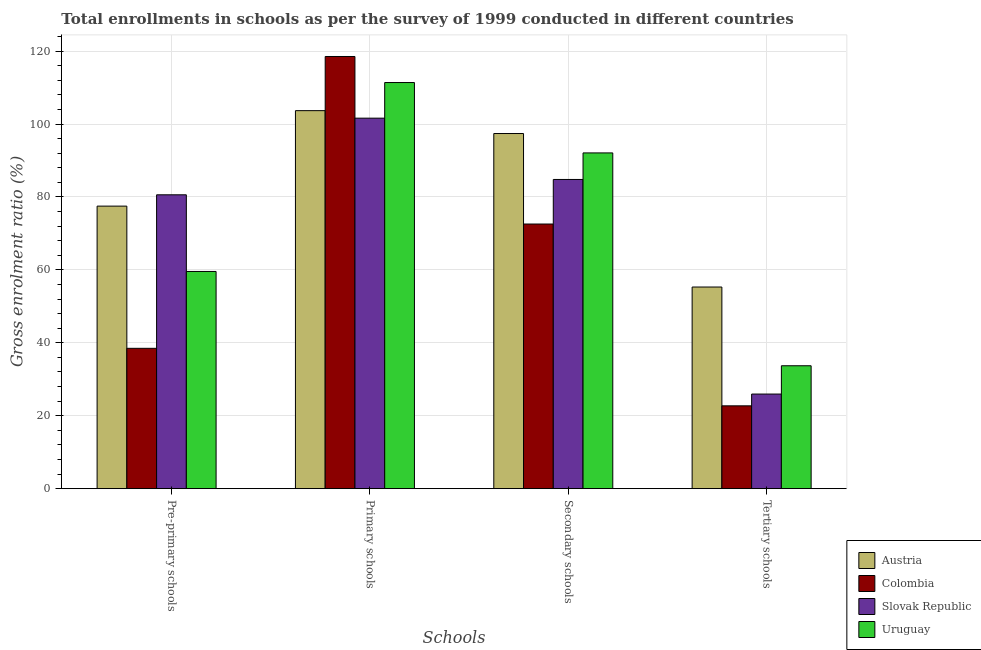How many different coloured bars are there?
Your answer should be compact. 4. Are the number of bars per tick equal to the number of legend labels?
Make the answer very short. Yes. How many bars are there on the 2nd tick from the left?
Your response must be concise. 4. How many bars are there on the 2nd tick from the right?
Offer a very short reply. 4. What is the label of the 1st group of bars from the left?
Your answer should be compact. Pre-primary schools. What is the gross enrolment ratio in pre-primary schools in Uruguay?
Keep it short and to the point. 59.57. Across all countries, what is the maximum gross enrolment ratio in pre-primary schools?
Ensure brevity in your answer.  80.59. Across all countries, what is the minimum gross enrolment ratio in secondary schools?
Offer a terse response. 72.58. In which country was the gross enrolment ratio in primary schools minimum?
Your answer should be very brief. Slovak Republic. What is the total gross enrolment ratio in secondary schools in the graph?
Your answer should be compact. 346.85. What is the difference between the gross enrolment ratio in tertiary schools in Uruguay and that in Colombia?
Your response must be concise. 10.99. What is the difference between the gross enrolment ratio in pre-primary schools in Austria and the gross enrolment ratio in primary schools in Colombia?
Make the answer very short. -41.03. What is the average gross enrolment ratio in tertiary schools per country?
Your answer should be very brief. 34.42. What is the difference between the gross enrolment ratio in tertiary schools and gross enrolment ratio in pre-primary schools in Austria?
Give a very brief answer. -22.19. In how many countries, is the gross enrolment ratio in primary schools greater than 64 %?
Provide a short and direct response. 4. What is the ratio of the gross enrolment ratio in primary schools in Austria to that in Slovak Republic?
Provide a short and direct response. 1.02. Is the gross enrolment ratio in pre-primary schools in Uruguay less than that in Colombia?
Give a very brief answer. No. What is the difference between the highest and the second highest gross enrolment ratio in primary schools?
Ensure brevity in your answer.  7.14. What is the difference between the highest and the lowest gross enrolment ratio in primary schools?
Your answer should be very brief. 16.91. Is it the case that in every country, the sum of the gross enrolment ratio in secondary schools and gross enrolment ratio in primary schools is greater than the sum of gross enrolment ratio in tertiary schools and gross enrolment ratio in pre-primary schools?
Offer a terse response. Yes. What does the 3rd bar from the left in Primary schools represents?
Make the answer very short. Slovak Republic. How many bars are there?
Provide a succinct answer. 16. Are all the bars in the graph horizontal?
Provide a short and direct response. No. How many countries are there in the graph?
Ensure brevity in your answer.  4. Are the values on the major ticks of Y-axis written in scientific E-notation?
Offer a very short reply. No. Does the graph contain grids?
Your response must be concise. Yes. Where does the legend appear in the graph?
Your response must be concise. Bottom right. How many legend labels are there?
Offer a very short reply. 4. What is the title of the graph?
Offer a very short reply. Total enrollments in schools as per the survey of 1999 conducted in different countries. What is the label or title of the X-axis?
Your answer should be compact. Schools. What is the label or title of the Y-axis?
Your answer should be very brief. Gross enrolment ratio (%). What is the Gross enrolment ratio (%) in Austria in Pre-primary schools?
Make the answer very short. 77.49. What is the Gross enrolment ratio (%) in Colombia in Pre-primary schools?
Offer a terse response. 38.49. What is the Gross enrolment ratio (%) in Slovak Republic in Pre-primary schools?
Offer a very short reply. 80.59. What is the Gross enrolment ratio (%) of Uruguay in Pre-primary schools?
Provide a short and direct response. 59.57. What is the Gross enrolment ratio (%) in Austria in Primary schools?
Your answer should be compact. 103.67. What is the Gross enrolment ratio (%) of Colombia in Primary schools?
Make the answer very short. 118.52. What is the Gross enrolment ratio (%) in Slovak Republic in Primary schools?
Offer a terse response. 101.61. What is the Gross enrolment ratio (%) in Uruguay in Primary schools?
Your response must be concise. 111.38. What is the Gross enrolment ratio (%) in Austria in Secondary schools?
Keep it short and to the point. 97.39. What is the Gross enrolment ratio (%) of Colombia in Secondary schools?
Provide a short and direct response. 72.58. What is the Gross enrolment ratio (%) in Slovak Republic in Secondary schools?
Make the answer very short. 84.8. What is the Gross enrolment ratio (%) in Uruguay in Secondary schools?
Provide a succinct answer. 92.08. What is the Gross enrolment ratio (%) in Austria in Tertiary schools?
Your answer should be very brief. 55.3. What is the Gross enrolment ratio (%) of Colombia in Tertiary schools?
Make the answer very short. 22.72. What is the Gross enrolment ratio (%) in Slovak Republic in Tertiary schools?
Keep it short and to the point. 25.95. What is the Gross enrolment ratio (%) in Uruguay in Tertiary schools?
Give a very brief answer. 33.71. Across all Schools, what is the maximum Gross enrolment ratio (%) of Austria?
Offer a very short reply. 103.67. Across all Schools, what is the maximum Gross enrolment ratio (%) in Colombia?
Your answer should be compact. 118.52. Across all Schools, what is the maximum Gross enrolment ratio (%) in Slovak Republic?
Keep it short and to the point. 101.61. Across all Schools, what is the maximum Gross enrolment ratio (%) in Uruguay?
Your response must be concise. 111.38. Across all Schools, what is the minimum Gross enrolment ratio (%) of Austria?
Provide a short and direct response. 55.3. Across all Schools, what is the minimum Gross enrolment ratio (%) in Colombia?
Ensure brevity in your answer.  22.72. Across all Schools, what is the minimum Gross enrolment ratio (%) of Slovak Republic?
Offer a terse response. 25.95. Across all Schools, what is the minimum Gross enrolment ratio (%) in Uruguay?
Keep it short and to the point. 33.71. What is the total Gross enrolment ratio (%) of Austria in the graph?
Offer a terse response. 333.85. What is the total Gross enrolment ratio (%) of Colombia in the graph?
Your answer should be compact. 252.31. What is the total Gross enrolment ratio (%) in Slovak Republic in the graph?
Ensure brevity in your answer.  292.94. What is the total Gross enrolment ratio (%) of Uruguay in the graph?
Offer a very short reply. 296.73. What is the difference between the Gross enrolment ratio (%) of Austria in Pre-primary schools and that in Primary schools?
Provide a succinct answer. -26.18. What is the difference between the Gross enrolment ratio (%) in Colombia in Pre-primary schools and that in Primary schools?
Provide a short and direct response. -80.03. What is the difference between the Gross enrolment ratio (%) of Slovak Republic in Pre-primary schools and that in Primary schools?
Your response must be concise. -21.02. What is the difference between the Gross enrolment ratio (%) of Uruguay in Pre-primary schools and that in Primary schools?
Keep it short and to the point. -51.81. What is the difference between the Gross enrolment ratio (%) in Austria in Pre-primary schools and that in Secondary schools?
Your answer should be very brief. -19.9. What is the difference between the Gross enrolment ratio (%) of Colombia in Pre-primary schools and that in Secondary schools?
Provide a succinct answer. -34.09. What is the difference between the Gross enrolment ratio (%) in Slovak Republic in Pre-primary schools and that in Secondary schools?
Your response must be concise. -4.21. What is the difference between the Gross enrolment ratio (%) in Uruguay in Pre-primary schools and that in Secondary schools?
Offer a very short reply. -32.51. What is the difference between the Gross enrolment ratio (%) of Austria in Pre-primary schools and that in Tertiary schools?
Provide a short and direct response. 22.19. What is the difference between the Gross enrolment ratio (%) in Colombia in Pre-primary schools and that in Tertiary schools?
Provide a succinct answer. 15.77. What is the difference between the Gross enrolment ratio (%) of Slovak Republic in Pre-primary schools and that in Tertiary schools?
Offer a terse response. 54.64. What is the difference between the Gross enrolment ratio (%) of Uruguay in Pre-primary schools and that in Tertiary schools?
Your answer should be very brief. 25.86. What is the difference between the Gross enrolment ratio (%) in Austria in Primary schools and that in Secondary schools?
Make the answer very short. 6.28. What is the difference between the Gross enrolment ratio (%) in Colombia in Primary schools and that in Secondary schools?
Provide a short and direct response. 45.94. What is the difference between the Gross enrolment ratio (%) in Slovak Republic in Primary schools and that in Secondary schools?
Your answer should be very brief. 16.81. What is the difference between the Gross enrolment ratio (%) of Uruguay in Primary schools and that in Secondary schools?
Offer a very short reply. 19.3. What is the difference between the Gross enrolment ratio (%) in Austria in Primary schools and that in Tertiary schools?
Make the answer very short. 48.37. What is the difference between the Gross enrolment ratio (%) of Colombia in Primary schools and that in Tertiary schools?
Offer a terse response. 95.8. What is the difference between the Gross enrolment ratio (%) of Slovak Republic in Primary schools and that in Tertiary schools?
Your response must be concise. 75.66. What is the difference between the Gross enrolment ratio (%) of Uruguay in Primary schools and that in Tertiary schools?
Give a very brief answer. 77.67. What is the difference between the Gross enrolment ratio (%) in Austria in Secondary schools and that in Tertiary schools?
Your answer should be compact. 42.09. What is the difference between the Gross enrolment ratio (%) of Colombia in Secondary schools and that in Tertiary schools?
Offer a terse response. 49.86. What is the difference between the Gross enrolment ratio (%) in Slovak Republic in Secondary schools and that in Tertiary schools?
Ensure brevity in your answer.  58.85. What is the difference between the Gross enrolment ratio (%) of Uruguay in Secondary schools and that in Tertiary schools?
Ensure brevity in your answer.  58.37. What is the difference between the Gross enrolment ratio (%) of Austria in Pre-primary schools and the Gross enrolment ratio (%) of Colombia in Primary schools?
Ensure brevity in your answer.  -41.03. What is the difference between the Gross enrolment ratio (%) of Austria in Pre-primary schools and the Gross enrolment ratio (%) of Slovak Republic in Primary schools?
Ensure brevity in your answer.  -24.12. What is the difference between the Gross enrolment ratio (%) of Austria in Pre-primary schools and the Gross enrolment ratio (%) of Uruguay in Primary schools?
Make the answer very short. -33.89. What is the difference between the Gross enrolment ratio (%) of Colombia in Pre-primary schools and the Gross enrolment ratio (%) of Slovak Republic in Primary schools?
Make the answer very short. -63.12. What is the difference between the Gross enrolment ratio (%) of Colombia in Pre-primary schools and the Gross enrolment ratio (%) of Uruguay in Primary schools?
Ensure brevity in your answer.  -72.89. What is the difference between the Gross enrolment ratio (%) of Slovak Republic in Pre-primary schools and the Gross enrolment ratio (%) of Uruguay in Primary schools?
Make the answer very short. -30.79. What is the difference between the Gross enrolment ratio (%) of Austria in Pre-primary schools and the Gross enrolment ratio (%) of Colombia in Secondary schools?
Keep it short and to the point. 4.91. What is the difference between the Gross enrolment ratio (%) in Austria in Pre-primary schools and the Gross enrolment ratio (%) in Slovak Republic in Secondary schools?
Offer a very short reply. -7.31. What is the difference between the Gross enrolment ratio (%) of Austria in Pre-primary schools and the Gross enrolment ratio (%) of Uruguay in Secondary schools?
Your answer should be very brief. -14.59. What is the difference between the Gross enrolment ratio (%) in Colombia in Pre-primary schools and the Gross enrolment ratio (%) in Slovak Republic in Secondary schools?
Provide a short and direct response. -46.31. What is the difference between the Gross enrolment ratio (%) in Colombia in Pre-primary schools and the Gross enrolment ratio (%) in Uruguay in Secondary schools?
Offer a terse response. -53.59. What is the difference between the Gross enrolment ratio (%) in Slovak Republic in Pre-primary schools and the Gross enrolment ratio (%) in Uruguay in Secondary schools?
Keep it short and to the point. -11.49. What is the difference between the Gross enrolment ratio (%) in Austria in Pre-primary schools and the Gross enrolment ratio (%) in Colombia in Tertiary schools?
Keep it short and to the point. 54.77. What is the difference between the Gross enrolment ratio (%) in Austria in Pre-primary schools and the Gross enrolment ratio (%) in Slovak Republic in Tertiary schools?
Offer a very short reply. 51.54. What is the difference between the Gross enrolment ratio (%) in Austria in Pre-primary schools and the Gross enrolment ratio (%) in Uruguay in Tertiary schools?
Give a very brief answer. 43.78. What is the difference between the Gross enrolment ratio (%) in Colombia in Pre-primary schools and the Gross enrolment ratio (%) in Slovak Republic in Tertiary schools?
Provide a succinct answer. 12.54. What is the difference between the Gross enrolment ratio (%) in Colombia in Pre-primary schools and the Gross enrolment ratio (%) in Uruguay in Tertiary schools?
Provide a succinct answer. 4.78. What is the difference between the Gross enrolment ratio (%) in Slovak Republic in Pre-primary schools and the Gross enrolment ratio (%) in Uruguay in Tertiary schools?
Your answer should be very brief. 46.88. What is the difference between the Gross enrolment ratio (%) in Austria in Primary schools and the Gross enrolment ratio (%) in Colombia in Secondary schools?
Give a very brief answer. 31.09. What is the difference between the Gross enrolment ratio (%) of Austria in Primary schools and the Gross enrolment ratio (%) of Slovak Republic in Secondary schools?
Provide a short and direct response. 18.87. What is the difference between the Gross enrolment ratio (%) in Austria in Primary schools and the Gross enrolment ratio (%) in Uruguay in Secondary schools?
Keep it short and to the point. 11.59. What is the difference between the Gross enrolment ratio (%) in Colombia in Primary schools and the Gross enrolment ratio (%) in Slovak Republic in Secondary schools?
Your response must be concise. 33.72. What is the difference between the Gross enrolment ratio (%) in Colombia in Primary schools and the Gross enrolment ratio (%) in Uruguay in Secondary schools?
Provide a succinct answer. 26.44. What is the difference between the Gross enrolment ratio (%) of Slovak Republic in Primary schools and the Gross enrolment ratio (%) of Uruguay in Secondary schools?
Your answer should be compact. 9.53. What is the difference between the Gross enrolment ratio (%) of Austria in Primary schools and the Gross enrolment ratio (%) of Colombia in Tertiary schools?
Make the answer very short. 80.95. What is the difference between the Gross enrolment ratio (%) in Austria in Primary schools and the Gross enrolment ratio (%) in Slovak Republic in Tertiary schools?
Keep it short and to the point. 77.72. What is the difference between the Gross enrolment ratio (%) of Austria in Primary schools and the Gross enrolment ratio (%) of Uruguay in Tertiary schools?
Your answer should be very brief. 69.96. What is the difference between the Gross enrolment ratio (%) of Colombia in Primary schools and the Gross enrolment ratio (%) of Slovak Republic in Tertiary schools?
Provide a succinct answer. 92.57. What is the difference between the Gross enrolment ratio (%) of Colombia in Primary schools and the Gross enrolment ratio (%) of Uruguay in Tertiary schools?
Make the answer very short. 84.81. What is the difference between the Gross enrolment ratio (%) in Slovak Republic in Primary schools and the Gross enrolment ratio (%) in Uruguay in Tertiary schools?
Offer a terse response. 67.9. What is the difference between the Gross enrolment ratio (%) of Austria in Secondary schools and the Gross enrolment ratio (%) of Colombia in Tertiary schools?
Offer a terse response. 74.67. What is the difference between the Gross enrolment ratio (%) of Austria in Secondary schools and the Gross enrolment ratio (%) of Slovak Republic in Tertiary schools?
Give a very brief answer. 71.45. What is the difference between the Gross enrolment ratio (%) of Austria in Secondary schools and the Gross enrolment ratio (%) of Uruguay in Tertiary schools?
Provide a short and direct response. 63.68. What is the difference between the Gross enrolment ratio (%) in Colombia in Secondary schools and the Gross enrolment ratio (%) in Slovak Republic in Tertiary schools?
Keep it short and to the point. 46.63. What is the difference between the Gross enrolment ratio (%) of Colombia in Secondary schools and the Gross enrolment ratio (%) of Uruguay in Tertiary schools?
Your response must be concise. 38.87. What is the difference between the Gross enrolment ratio (%) in Slovak Republic in Secondary schools and the Gross enrolment ratio (%) in Uruguay in Tertiary schools?
Offer a terse response. 51.09. What is the average Gross enrolment ratio (%) of Austria per Schools?
Keep it short and to the point. 83.46. What is the average Gross enrolment ratio (%) of Colombia per Schools?
Offer a very short reply. 63.08. What is the average Gross enrolment ratio (%) in Slovak Republic per Schools?
Your response must be concise. 73.24. What is the average Gross enrolment ratio (%) in Uruguay per Schools?
Provide a short and direct response. 74.18. What is the difference between the Gross enrolment ratio (%) of Austria and Gross enrolment ratio (%) of Colombia in Pre-primary schools?
Give a very brief answer. 39. What is the difference between the Gross enrolment ratio (%) in Austria and Gross enrolment ratio (%) in Slovak Republic in Pre-primary schools?
Your response must be concise. -3.1. What is the difference between the Gross enrolment ratio (%) in Austria and Gross enrolment ratio (%) in Uruguay in Pre-primary schools?
Keep it short and to the point. 17.92. What is the difference between the Gross enrolment ratio (%) in Colombia and Gross enrolment ratio (%) in Slovak Republic in Pre-primary schools?
Provide a short and direct response. -42.1. What is the difference between the Gross enrolment ratio (%) in Colombia and Gross enrolment ratio (%) in Uruguay in Pre-primary schools?
Keep it short and to the point. -21.08. What is the difference between the Gross enrolment ratio (%) in Slovak Republic and Gross enrolment ratio (%) in Uruguay in Pre-primary schools?
Your response must be concise. 21.02. What is the difference between the Gross enrolment ratio (%) of Austria and Gross enrolment ratio (%) of Colombia in Primary schools?
Your answer should be very brief. -14.85. What is the difference between the Gross enrolment ratio (%) of Austria and Gross enrolment ratio (%) of Slovak Republic in Primary schools?
Your answer should be very brief. 2.06. What is the difference between the Gross enrolment ratio (%) of Austria and Gross enrolment ratio (%) of Uruguay in Primary schools?
Offer a very short reply. -7.71. What is the difference between the Gross enrolment ratio (%) in Colombia and Gross enrolment ratio (%) in Slovak Republic in Primary schools?
Give a very brief answer. 16.91. What is the difference between the Gross enrolment ratio (%) of Colombia and Gross enrolment ratio (%) of Uruguay in Primary schools?
Offer a terse response. 7.14. What is the difference between the Gross enrolment ratio (%) of Slovak Republic and Gross enrolment ratio (%) of Uruguay in Primary schools?
Give a very brief answer. -9.77. What is the difference between the Gross enrolment ratio (%) of Austria and Gross enrolment ratio (%) of Colombia in Secondary schools?
Provide a short and direct response. 24.82. What is the difference between the Gross enrolment ratio (%) of Austria and Gross enrolment ratio (%) of Slovak Republic in Secondary schools?
Keep it short and to the point. 12.6. What is the difference between the Gross enrolment ratio (%) of Austria and Gross enrolment ratio (%) of Uruguay in Secondary schools?
Give a very brief answer. 5.31. What is the difference between the Gross enrolment ratio (%) in Colombia and Gross enrolment ratio (%) in Slovak Republic in Secondary schools?
Your answer should be very brief. -12.22. What is the difference between the Gross enrolment ratio (%) in Colombia and Gross enrolment ratio (%) in Uruguay in Secondary schools?
Your response must be concise. -19.5. What is the difference between the Gross enrolment ratio (%) of Slovak Republic and Gross enrolment ratio (%) of Uruguay in Secondary schools?
Your answer should be compact. -7.28. What is the difference between the Gross enrolment ratio (%) in Austria and Gross enrolment ratio (%) in Colombia in Tertiary schools?
Your response must be concise. 32.58. What is the difference between the Gross enrolment ratio (%) in Austria and Gross enrolment ratio (%) in Slovak Republic in Tertiary schools?
Make the answer very short. 29.35. What is the difference between the Gross enrolment ratio (%) of Austria and Gross enrolment ratio (%) of Uruguay in Tertiary schools?
Keep it short and to the point. 21.59. What is the difference between the Gross enrolment ratio (%) in Colombia and Gross enrolment ratio (%) in Slovak Republic in Tertiary schools?
Your response must be concise. -3.23. What is the difference between the Gross enrolment ratio (%) in Colombia and Gross enrolment ratio (%) in Uruguay in Tertiary schools?
Provide a short and direct response. -10.99. What is the difference between the Gross enrolment ratio (%) in Slovak Republic and Gross enrolment ratio (%) in Uruguay in Tertiary schools?
Give a very brief answer. -7.76. What is the ratio of the Gross enrolment ratio (%) in Austria in Pre-primary schools to that in Primary schools?
Give a very brief answer. 0.75. What is the ratio of the Gross enrolment ratio (%) in Colombia in Pre-primary schools to that in Primary schools?
Offer a very short reply. 0.32. What is the ratio of the Gross enrolment ratio (%) in Slovak Republic in Pre-primary schools to that in Primary schools?
Provide a succinct answer. 0.79. What is the ratio of the Gross enrolment ratio (%) in Uruguay in Pre-primary schools to that in Primary schools?
Your answer should be very brief. 0.53. What is the ratio of the Gross enrolment ratio (%) in Austria in Pre-primary schools to that in Secondary schools?
Your response must be concise. 0.8. What is the ratio of the Gross enrolment ratio (%) in Colombia in Pre-primary schools to that in Secondary schools?
Offer a very short reply. 0.53. What is the ratio of the Gross enrolment ratio (%) in Slovak Republic in Pre-primary schools to that in Secondary schools?
Your response must be concise. 0.95. What is the ratio of the Gross enrolment ratio (%) of Uruguay in Pre-primary schools to that in Secondary schools?
Your response must be concise. 0.65. What is the ratio of the Gross enrolment ratio (%) of Austria in Pre-primary schools to that in Tertiary schools?
Your answer should be very brief. 1.4. What is the ratio of the Gross enrolment ratio (%) in Colombia in Pre-primary schools to that in Tertiary schools?
Offer a terse response. 1.69. What is the ratio of the Gross enrolment ratio (%) of Slovak Republic in Pre-primary schools to that in Tertiary schools?
Give a very brief answer. 3.11. What is the ratio of the Gross enrolment ratio (%) in Uruguay in Pre-primary schools to that in Tertiary schools?
Ensure brevity in your answer.  1.77. What is the ratio of the Gross enrolment ratio (%) of Austria in Primary schools to that in Secondary schools?
Ensure brevity in your answer.  1.06. What is the ratio of the Gross enrolment ratio (%) in Colombia in Primary schools to that in Secondary schools?
Provide a short and direct response. 1.63. What is the ratio of the Gross enrolment ratio (%) of Slovak Republic in Primary schools to that in Secondary schools?
Make the answer very short. 1.2. What is the ratio of the Gross enrolment ratio (%) of Uruguay in Primary schools to that in Secondary schools?
Keep it short and to the point. 1.21. What is the ratio of the Gross enrolment ratio (%) in Austria in Primary schools to that in Tertiary schools?
Ensure brevity in your answer.  1.87. What is the ratio of the Gross enrolment ratio (%) of Colombia in Primary schools to that in Tertiary schools?
Keep it short and to the point. 5.22. What is the ratio of the Gross enrolment ratio (%) in Slovak Republic in Primary schools to that in Tertiary schools?
Ensure brevity in your answer.  3.92. What is the ratio of the Gross enrolment ratio (%) of Uruguay in Primary schools to that in Tertiary schools?
Provide a short and direct response. 3.3. What is the ratio of the Gross enrolment ratio (%) in Austria in Secondary schools to that in Tertiary schools?
Offer a terse response. 1.76. What is the ratio of the Gross enrolment ratio (%) of Colombia in Secondary schools to that in Tertiary schools?
Your response must be concise. 3.19. What is the ratio of the Gross enrolment ratio (%) of Slovak Republic in Secondary schools to that in Tertiary schools?
Provide a succinct answer. 3.27. What is the ratio of the Gross enrolment ratio (%) of Uruguay in Secondary schools to that in Tertiary schools?
Give a very brief answer. 2.73. What is the difference between the highest and the second highest Gross enrolment ratio (%) in Austria?
Offer a very short reply. 6.28. What is the difference between the highest and the second highest Gross enrolment ratio (%) of Colombia?
Give a very brief answer. 45.94. What is the difference between the highest and the second highest Gross enrolment ratio (%) in Slovak Republic?
Ensure brevity in your answer.  16.81. What is the difference between the highest and the second highest Gross enrolment ratio (%) of Uruguay?
Your answer should be compact. 19.3. What is the difference between the highest and the lowest Gross enrolment ratio (%) of Austria?
Give a very brief answer. 48.37. What is the difference between the highest and the lowest Gross enrolment ratio (%) in Colombia?
Offer a terse response. 95.8. What is the difference between the highest and the lowest Gross enrolment ratio (%) in Slovak Republic?
Make the answer very short. 75.66. What is the difference between the highest and the lowest Gross enrolment ratio (%) in Uruguay?
Ensure brevity in your answer.  77.67. 